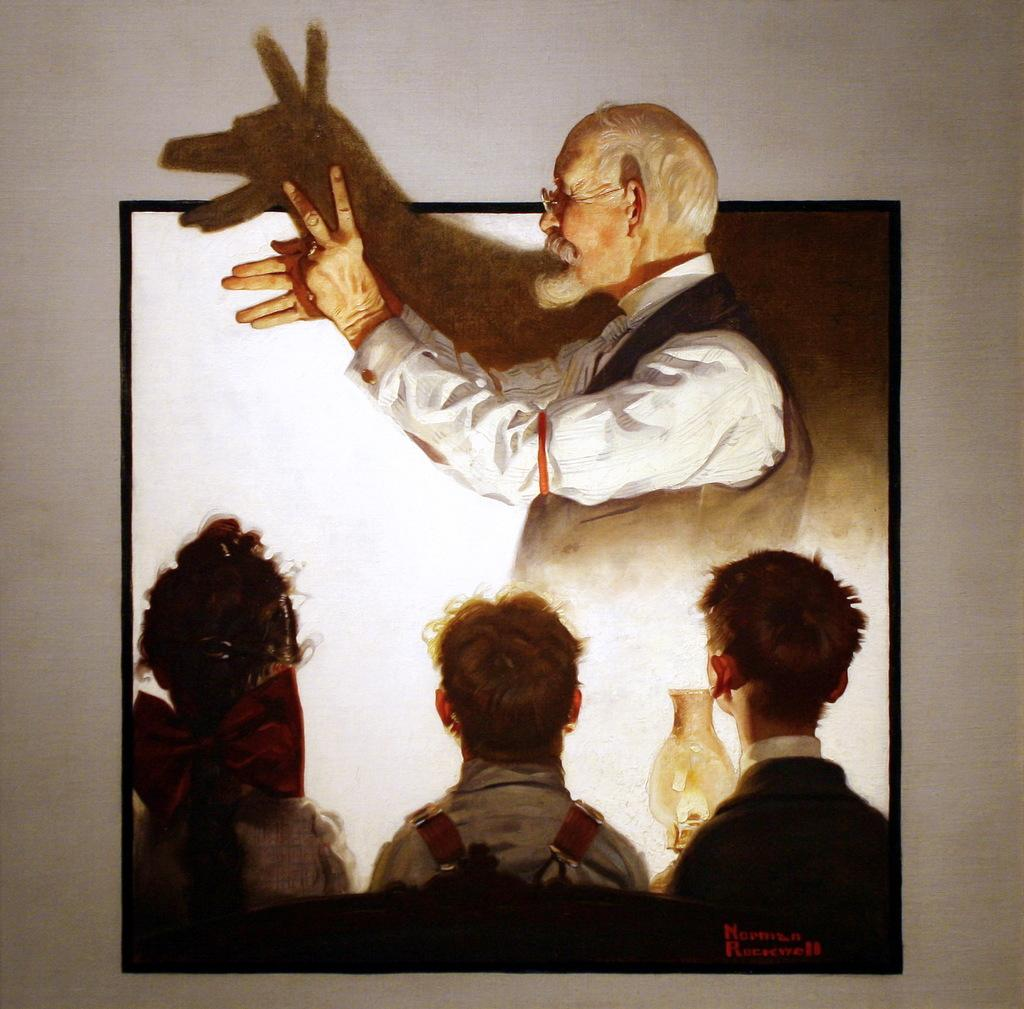What is located in the middle of the image? There is a frame in the middle of the image. What can be seen within the frame? There are people visible within the frame. What type of lace is being used to hold the people within the frame? There is no lace present in the image; the people are visible within a frame, which is a solid structure. 